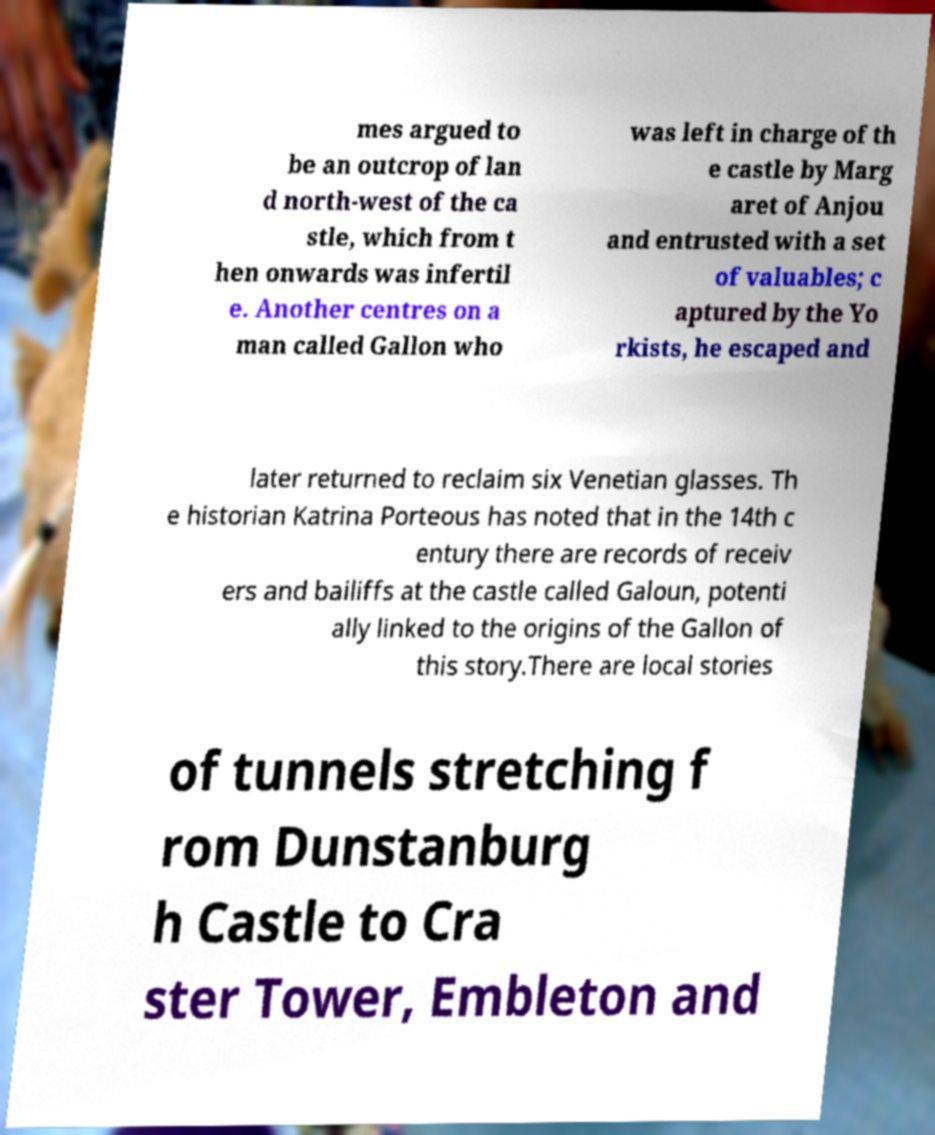For documentation purposes, I need the text within this image transcribed. Could you provide that? mes argued to be an outcrop of lan d north-west of the ca stle, which from t hen onwards was infertil e. Another centres on a man called Gallon who was left in charge of th e castle by Marg aret of Anjou and entrusted with a set of valuables; c aptured by the Yo rkists, he escaped and later returned to reclaim six Venetian glasses. Th e historian Katrina Porteous has noted that in the 14th c entury there are records of receiv ers and bailiffs at the castle called Galoun, potenti ally linked to the origins of the Gallon of this story.There are local stories of tunnels stretching f rom Dunstanburg h Castle to Cra ster Tower, Embleton and 